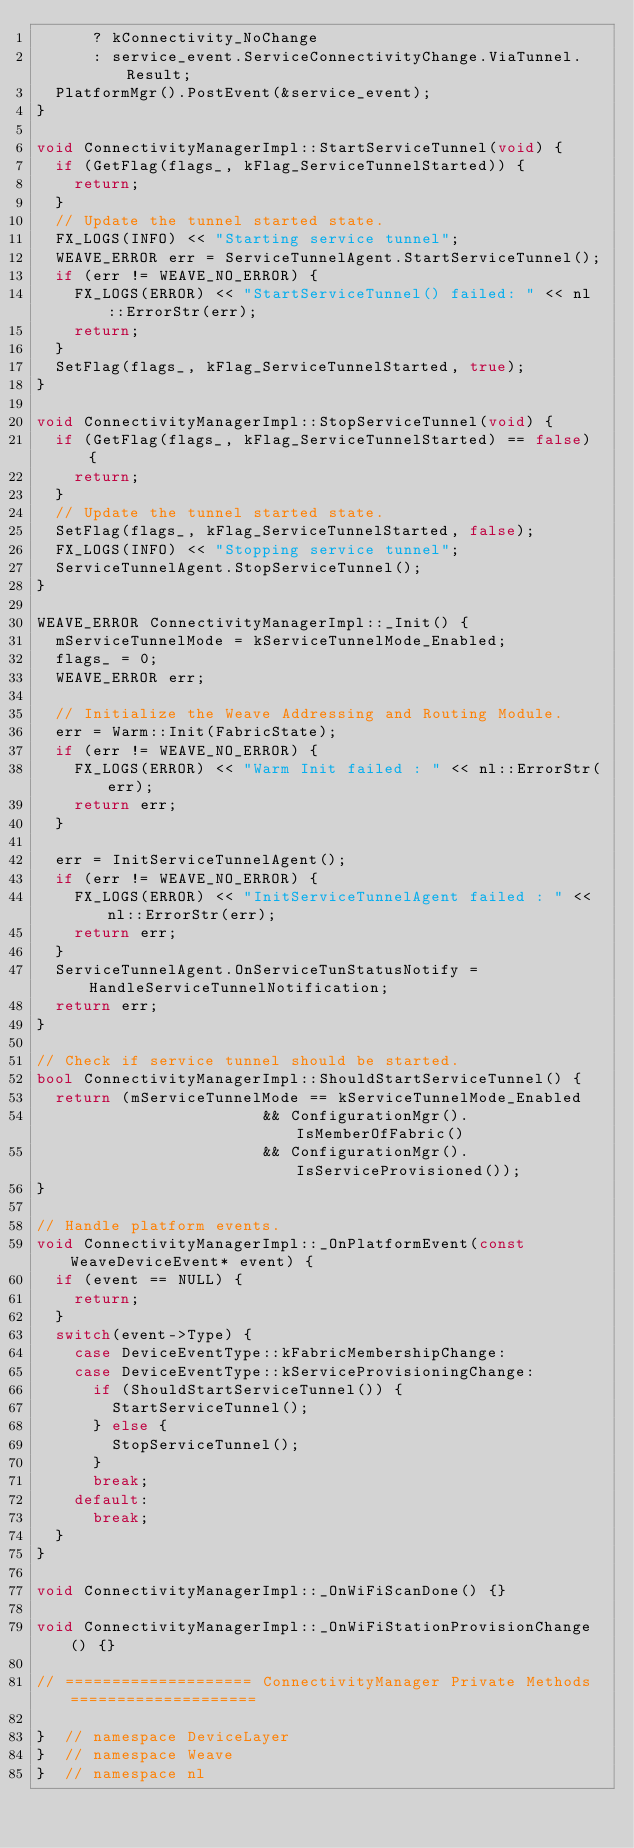Convert code to text. <code><loc_0><loc_0><loc_500><loc_500><_C++_>      ? kConnectivity_NoChange
      : service_event.ServiceConnectivityChange.ViaTunnel.Result;
  PlatformMgr().PostEvent(&service_event);
}

void ConnectivityManagerImpl::StartServiceTunnel(void) {
  if (GetFlag(flags_, kFlag_ServiceTunnelStarted)) {
    return;
  }
  // Update the tunnel started state.
  FX_LOGS(INFO) << "Starting service tunnel";
  WEAVE_ERROR err = ServiceTunnelAgent.StartServiceTunnel();
  if (err != WEAVE_NO_ERROR) {
    FX_LOGS(ERROR) << "StartServiceTunnel() failed: " << nl::ErrorStr(err);
    return;
  }
  SetFlag(flags_, kFlag_ServiceTunnelStarted, true);
}

void ConnectivityManagerImpl::StopServiceTunnel(void) {
  if (GetFlag(flags_, kFlag_ServiceTunnelStarted) == false) {
    return;
  }
  // Update the tunnel started state.
  SetFlag(flags_, kFlag_ServiceTunnelStarted, false);
  FX_LOGS(INFO) << "Stopping service tunnel";
  ServiceTunnelAgent.StopServiceTunnel();
}

WEAVE_ERROR ConnectivityManagerImpl::_Init() {
  mServiceTunnelMode = kServiceTunnelMode_Enabled;
  flags_ = 0;
  WEAVE_ERROR err;

  // Initialize the Weave Addressing and Routing Module.
  err = Warm::Init(FabricState);
  if (err != WEAVE_NO_ERROR) {
    FX_LOGS(ERROR) << "Warm Init failed : " << nl::ErrorStr(err);
    return err;
  }

  err = InitServiceTunnelAgent();
  if (err != WEAVE_NO_ERROR) {
    FX_LOGS(ERROR) << "InitServiceTunnelAgent failed : " << nl::ErrorStr(err);
    return err;
  }
  ServiceTunnelAgent.OnServiceTunStatusNotify = HandleServiceTunnelNotification;
  return err;
}

// Check if service tunnel should be started.
bool ConnectivityManagerImpl::ShouldStartServiceTunnel() {
  return (mServiceTunnelMode == kServiceTunnelMode_Enabled
                        && ConfigurationMgr().IsMemberOfFabric()
                        && ConfigurationMgr().IsServiceProvisioned());
}

// Handle platform events.
void ConnectivityManagerImpl::_OnPlatformEvent(const WeaveDeviceEvent* event) {
  if (event == NULL) {
    return;
  }
  switch(event->Type) {
    case DeviceEventType::kFabricMembershipChange:
    case DeviceEventType::kServiceProvisioningChange:
      if (ShouldStartServiceTunnel()) {
        StartServiceTunnel();
      } else {
        StopServiceTunnel();
      }
      break;
    default:
      break;
  }
}

void ConnectivityManagerImpl::_OnWiFiScanDone() {}

void ConnectivityManagerImpl::_OnWiFiStationProvisionChange() {}

// ==================== ConnectivityManager Private Methods ====================

}  // namespace DeviceLayer
}  // namespace Weave
}  // namespace nl
</code> 